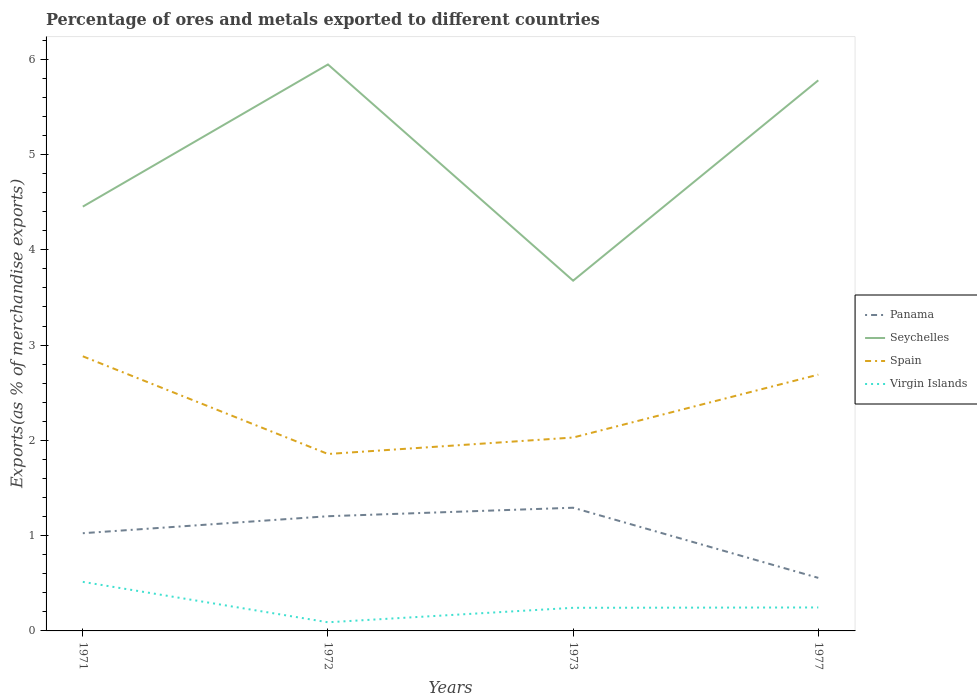How many different coloured lines are there?
Your answer should be very brief. 4. Is the number of lines equal to the number of legend labels?
Ensure brevity in your answer.  Yes. Across all years, what is the maximum percentage of exports to different countries in Panama?
Give a very brief answer. 0.56. In which year was the percentage of exports to different countries in Panama maximum?
Offer a very short reply. 1977. What is the total percentage of exports to different countries in Panama in the graph?
Offer a terse response. 0.65. What is the difference between the highest and the second highest percentage of exports to different countries in Seychelles?
Keep it short and to the point. 2.27. What is the difference between the highest and the lowest percentage of exports to different countries in Spain?
Ensure brevity in your answer.  2. Is the percentage of exports to different countries in Panama strictly greater than the percentage of exports to different countries in Spain over the years?
Provide a succinct answer. Yes. How many years are there in the graph?
Keep it short and to the point. 4. Does the graph contain grids?
Your response must be concise. No. What is the title of the graph?
Provide a succinct answer. Percentage of ores and metals exported to different countries. What is the label or title of the X-axis?
Make the answer very short. Years. What is the label or title of the Y-axis?
Your answer should be compact. Exports(as % of merchandise exports). What is the Exports(as % of merchandise exports) of Panama in 1971?
Your answer should be compact. 1.03. What is the Exports(as % of merchandise exports) in Seychelles in 1971?
Provide a short and direct response. 4.45. What is the Exports(as % of merchandise exports) of Spain in 1971?
Your answer should be very brief. 2.88. What is the Exports(as % of merchandise exports) of Virgin Islands in 1971?
Provide a succinct answer. 0.51. What is the Exports(as % of merchandise exports) in Panama in 1972?
Provide a short and direct response. 1.2. What is the Exports(as % of merchandise exports) in Seychelles in 1972?
Your answer should be very brief. 5.95. What is the Exports(as % of merchandise exports) of Spain in 1972?
Offer a very short reply. 1.86. What is the Exports(as % of merchandise exports) of Virgin Islands in 1972?
Ensure brevity in your answer.  0.09. What is the Exports(as % of merchandise exports) of Panama in 1973?
Your answer should be very brief. 1.29. What is the Exports(as % of merchandise exports) in Seychelles in 1973?
Keep it short and to the point. 3.68. What is the Exports(as % of merchandise exports) of Spain in 1973?
Offer a very short reply. 2.03. What is the Exports(as % of merchandise exports) in Virgin Islands in 1973?
Keep it short and to the point. 0.24. What is the Exports(as % of merchandise exports) of Panama in 1977?
Your response must be concise. 0.56. What is the Exports(as % of merchandise exports) of Seychelles in 1977?
Your answer should be compact. 5.78. What is the Exports(as % of merchandise exports) in Spain in 1977?
Your response must be concise. 2.69. What is the Exports(as % of merchandise exports) in Virgin Islands in 1977?
Offer a terse response. 0.25. Across all years, what is the maximum Exports(as % of merchandise exports) of Panama?
Offer a terse response. 1.29. Across all years, what is the maximum Exports(as % of merchandise exports) in Seychelles?
Make the answer very short. 5.95. Across all years, what is the maximum Exports(as % of merchandise exports) of Spain?
Give a very brief answer. 2.88. Across all years, what is the maximum Exports(as % of merchandise exports) in Virgin Islands?
Your answer should be very brief. 0.51. Across all years, what is the minimum Exports(as % of merchandise exports) in Panama?
Offer a very short reply. 0.56. Across all years, what is the minimum Exports(as % of merchandise exports) of Seychelles?
Your response must be concise. 3.68. Across all years, what is the minimum Exports(as % of merchandise exports) in Spain?
Make the answer very short. 1.86. Across all years, what is the minimum Exports(as % of merchandise exports) of Virgin Islands?
Your answer should be compact. 0.09. What is the total Exports(as % of merchandise exports) in Panama in the graph?
Provide a succinct answer. 4.08. What is the total Exports(as % of merchandise exports) in Seychelles in the graph?
Your response must be concise. 19.85. What is the total Exports(as % of merchandise exports) in Spain in the graph?
Give a very brief answer. 9.46. What is the total Exports(as % of merchandise exports) in Virgin Islands in the graph?
Offer a very short reply. 1.09. What is the difference between the Exports(as % of merchandise exports) in Panama in 1971 and that in 1972?
Your answer should be compact. -0.18. What is the difference between the Exports(as % of merchandise exports) of Seychelles in 1971 and that in 1972?
Keep it short and to the point. -1.49. What is the difference between the Exports(as % of merchandise exports) of Spain in 1971 and that in 1972?
Give a very brief answer. 1.03. What is the difference between the Exports(as % of merchandise exports) of Virgin Islands in 1971 and that in 1972?
Make the answer very short. 0.42. What is the difference between the Exports(as % of merchandise exports) in Panama in 1971 and that in 1973?
Offer a terse response. -0.27. What is the difference between the Exports(as % of merchandise exports) in Seychelles in 1971 and that in 1973?
Your answer should be compact. 0.78. What is the difference between the Exports(as % of merchandise exports) in Spain in 1971 and that in 1973?
Give a very brief answer. 0.85. What is the difference between the Exports(as % of merchandise exports) of Virgin Islands in 1971 and that in 1973?
Give a very brief answer. 0.27. What is the difference between the Exports(as % of merchandise exports) in Panama in 1971 and that in 1977?
Offer a very short reply. 0.47. What is the difference between the Exports(as % of merchandise exports) of Seychelles in 1971 and that in 1977?
Offer a very short reply. -1.33. What is the difference between the Exports(as % of merchandise exports) in Spain in 1971 and that in 1977?
Provide a short and direct response. 0.19. What is the difference between the Exports(as % of merchandise exports) of Virgin Islands in 1971 and that in 1977?
Offer a very short reply. 0.27. What is the difference between the Exports(as % of merchandise exports) of Panama in 1972 and that in 1973?
Your response must be concise. -0.09. What is the difference between the Exports(as % of merchandise exports) of Seychelles in 1972 and that in 1973?
Offer a terse response. 2.27. What is the difference between the Exports(as % of merchandise exports) in Spain in 1972 and that in 1973?
Your answer should be very brief. -0.17. What is the difference between the Exports(as % of merchandise exports) of Virgin Islands in 1972 and that in 1973?
Your answer should be compact. -0.15. What is the difference between the Exports(as % of merchandise exports) of Panama in 1972 and that in 1977?
Offer a very short reply. 0.65. What is the difference between the Exports(as % of merchandise exports) of Seychelles in 1972 and that in 1977?
Keep it short and to the point. 0.17. What is the difference between the Exports(as % of merchandise exports) of Spain in 1972 and that in 1977?
Keep it short and to the point. -0.83. What is the difference between the Exports(as % of merchandise exports) in Virgin Islands in 1972 and that in 1977?
Ensure brevity in your answer.  -0.16. What is the difference between the Exports(as % of merchandise exports) in Panama in 1973 and that in 1977?
Make the answer very short. 0.74. What is the difference between the Exports(as % of merchandise exports) of Seychelles in 1973 and that in 1977?
Keep it short and to the point. -2.1. What is the difference between the Exports(as % of merchandise exports) of Spain in 1973 and that in 1977?
Your answer should be very brief. -0.66. What is the difference between the Exports(as % of merchandise exports) in Virgin Islands in 1973 and that in 1977?
Your response must be concise. -0. What is the difference between the Exports(as % of merchandise exports) in Panama in 1971 and the Exports(as % of merchandise exports) in Seychelles in 1972?
Ensure brevity in your answer.  -4.92. What is the difference between the Exports(as % of merchandise exports) of Panama in 1971 and the Exports(as % of merchandise exports) of Spain in 1972?
Give a very brief answer. -0.83. What is the difference between the Exports(as % of merchandise exports) in Panama in 1971 and the Exports(as % of merchandise exports) in Virgin Islands in 1972?
Ensure brevity in your answer.  0.93. What is the difference between the Exports(as % of merchandise exports) of Seychelles in 1971 and the Exports(as % of merchandise exports) of Spain in 1972?
Give a very brief answer. 2.6. What is the difference between the Exports(as % of merchandise exports) of Seychelles in 1971 and the Exports(as % of merchandise exports) of Virgin Islands in 1972?
Make the answer very short. 4.36. What is the difference between the Exports(as % of merchandise exports) of Spain in 1971 and the Exports(as % of merchandise exports) of Virgin Islands in 1972?
Offer a terse response. 2.79. What is the difference between the Exports(as % of merchandise exports) of Panama in 1971 and the Exports(as % of merchandise exports) of Seychelles in 1973?
Keep it short and to the point. -2.65. What is the difference between the Exports(as % of merchandise exports) in Panama in 1971 and the Exports(as % of merchandise exports) in Spain in 1973?
Your response must be concise. -1. What is the difference between the Exports(as % of merchandise exports) in Panama in 1971 and the Exports(as % of merchandise exports) in Virgin Islands in 1973?
Your response must be concise. 0.78. What is the difference between the Exports(as % of merchandise exports) of Seychelles in 1971 and the Exports(as % of merchandise exports) of Spain in 1973?
Offer a very short reply. 2.42. What is the difference between the Exports(as % of merchandise exports) of Seychelles in 1971 and the Exports(as % of merchandise exports) of Virgin Islands in 1973?
Offer a terse response. 4.21. What is the difference between the Exports(as % of merchandise exports) in Spain in 1971 and the Exports(as % of merchandise exports) in Virgin Islands in 1973?
Your answer should be very brief. 2.64. What is the difference between the Exports(as % of merchandise exports) in Panama in 1971 and the Exports(as % of merchandise exports) in Seychelles in 1977?
Provide a succinct answer. -4.75. What is the difference between the Exports(as % of merchandise exports) of Panama in 1971 and the Exports(as % of merchandise exports) of Spain in 1977?
Provide a short and direct response. -1.66. What is the difference between the Exports(as % of merchandise exports) in Panama in 1971 and the Exports(as % of merchandise exports) in Virgin Islands in 1977?
Provide a succinct answer. 0.78. What is the difference between the Exports(as % of merchandise exports) of Seychelles in 1971 and the Exports(as % of merchandise exports) of Spain in 1977?
Provide a short and direct response. 1.76. What is the difference between the Exports(as % of merchandise exports) of Seychelles in 1971 and the Exports(as % of merchandise exports) of Virgin Islands in 1977?
Give a very brief answer. 4.21. What is the difference between the Exports(as % of merchandise exports) of Spain in 1971 and the Exports(as % of merchandise exports) of Virgin Islands in 1977?
Your answer should be very brief. 2.64. What is the difference between the Exports(as % of merchandise exports) of Panama in 1972 and the Exports(as % of merchandise exports) of Seychelles in 1973?
Your answer should be very brief. -2.47. What is the difference between the Exports(as % of merchandise exports) in Panama in 1972 and the Exports(as % of merchandise exports) in Spain in 1973?
Your answer should be compact. -0.83. What is the difference between the Exports(as % of merchandise exports) of Panama in 1972 and the Exports(as % of merchandise exports) of Virgin Islands in 1973?
Offer a terse response. 0.96. What is the difference between the Exports(as % of merchandise exports) of Seychelles in 1972 and the Exports(as % of merchandise exports) of Spain in 1973?
Offer a terse response. 3.92. What is the difference between the Exports(as % of merchandise exports) of Seychelles in 1972 and the Exports(as % of merchandise exports) of Virgin Islands in 1973?
Your answer should be very brief. 5.7. What is the difference between the Exports(as % of merchandise exports) in Spain in 1972 and the Exports(as % of merchandise exports) in Virgin Islands in 1973?
Offer a very short reply. 1.61. What is the difference between the Exports(as % of merchandise exports) of Panama in 1972 and the Exports(as % of merchandise exports) of Seychelles in 1977?
Offer a very short reply. -4.58. What is the difference between the Exports(as % of merchandise exports) in Panama in 1972 and the Exports(as % of merchandise exports) in Spain in 1977?
Make the answer very short. -1.49. What is the difference between the Exports(as % of merchandise exports) of Panama in 1972 and the Exports(as % of merchandise exports) of Virgin Islands in 1977?
Give a very brief answer. 0.96. What is the difference between the Exports(as % of merchandise exports) in Seychelles in 1972 and the Exports(as % of merchandise exports) in Spain in 1977?
Provide a succinct answer. 3.26. What is the difference between the Exports(as % of merchandise exports) in Seychelles in 1972 and the Exports(as % of merchandise exports) in Virgin Islands in 1977?
Give a very brief answer. 5.7. What is the difference between the Exports(as % of merchandise exports) of Spain in 1972 and the Exports(as % of merchandise exports) of Virgin Islands in 1977?
Make the answer very short. 1.61. What is the difference between the Exports(as % of merchandise exports) of Panama in 1973 and the Exports(as % of merchandise exports) of Seychelles in 1977?
Your response must be concise. -4.49. What is the difference between the Exports(as % of merchandise exports) in Panama in 1973 and the Exports(as % of merchandise exports) in Spain in 1977?
Offer a very short reply. -1.4. What is the difference between the Exports(as % of merchandise exports) of Panama in 1973 and the Exports(as % of merchandise exports) of Virgin Islands in 1977?
Offer a terse response. 1.05. What is the difference between the Exports(as % of merchandise exports) in Seychelles in 1973 and the Exports(as % of merchandise exports) in Spain in 1977?
Provide a succinct answer. 0.99. What is the difference between the Exports(as % of merchandise exports) of Seychelles in 1973 and the Exports(as % of merchandise exports) of Virgin Islands in 1977?
Offer a terse response. 3.43. What is the difference between the Exports(as % of merchandise exports) in Spain in 1973 and the Exports(as % of merchandise exports) in Virgin Islands in 1977?
Your answer should be very brief. 1.78. What is the average Exports(as % of merchandise exports) of Panama per year?
Keep it short and to the point. 1.02. What is the average Exports(as % of merchandise exports) in Seychelles per year?
Offer a very short reply. 4.96. What is the average Exports(as % of merchandise exports) of Spain per year?
Offer a terse response. 2.36. What is the average Exports(as % of merchandise exports) of Virgin Islands per year?
Ensure brevity in your answer.  0.27. In the year 1971, what is the difference between the Exports(as % of merchandise exports) of Panama and Exports(as % of merchandise exports) of Seychelles?
Ensure brevity in your answer.  -3.43. In the year 1971, what is the difference between the Exports(as % of merchandise exports) in Panama and Exports(as % of merchandise exports) in Spain?
Provide a succinct answer. -1.86. In the year 1971, what is the difference between the Exports(as % of merchandise exports) of Panama and Exports(as % of merchandise exports) of Virgin Islands?
Your answer should be very brief. 0.51. In the year 1971, what is the difference between the Exports(as % of merchandise exports) of Seychelles and Exports(as % of merchandise exports) of Spain?
Your response must be concise. 1.57. In the year 1971, what is the difference between the Exports(as % of merchandise exports) of Seychelles and Exports(as % of merchandise exports) of Virgin Islands?
Your answer should be very brief. 3.94. In the year 1971, what is the difference between the Exports(as % of merchandise exports) in Spain and Exports(as % of merchandise exports) in Virgin Islands?
Your response must be concise. 2.37. In the year 1972, what is the difference between the Exports(as % of merchandise exports) of Panama and Exports(as % of merchandise exports) of Seychelles?
Give a very brief answer. -4.74. In the year 1972, what is the difference between the Exports(as % of merchandise exports) of Panama and Exports(as % of merchandise exports) of Spain?
Ensure brevity in your answer.  -0.65. In the year 1972, what is the difference between the Exports(as % of merchandise exports) in Panama and Exports(as % of merchandise exports) in Virgin Islands?
Your answer should be compact. 1.11. In the year 1972, what is the difference between the Exports(as % of merchandise exports) in Seychelles and Exports(as % of merchandise exports) in Spain?
Ensure brevity in your answer.  4.09. In the year 1972, what is the difference between the Exports(as % of merchandise exports) of Seychelles and Exports(as % of merchandise exports) of Virgin Islands?
Give a very brief answer. 5.85. In the year 1972, what is the difference between the Exports(as % of merchandise exports) in Spain and Exports(as % of merchandise exports) in Virgin Islands?
Keep it short and to the point. 1.77. In the year 1973, what is the difference between the Exports(as % of merchandise exports) of Panama and Exports(as % of merchandise exports) of Seychelles?
Offer a terse response. -2.38. In the year 1973, what is the difference between the Exports(as % of merchandise exports) in Panama and Exports(as % of merchandise exports) in Spain?
Your answer should be very brief. -0.74. In the year 1973, what is the difference between the Exports(as % of merchandise exports) in Panama and Exports(as % of merchandise exports) in Virgin Islands?
Your answer should be very brief. 1.05. In the year 1973, what is the difference between the Exports(as % of merchandise exports) in Seychelles and Exports(as % of merchandise exports) in Spain?
Give a very brief answer. 1.65. In the year 1973, what is the difference between the Exports(as % of merchandise exports) of Seychelles and Exports(as % of merchandise exports) of Virgin Islands?
Keep it short and to the point. 3.43. In the year 1973, what is the difference between the Exports(as % of merchandise exports) in Spain and Exports(as % of merchandise exports) in Virgin Islands?
Your response must be concise. 1.79. In the year 1977, what is the difference between the Exports(as % of merchandise exports) of Panama and Exports(as % of merchandise exports) of Seychelles?
Keep it short and to the point. -5.22. In the year 1977, what is the difference between the Exports(as % of merchandise exports) of Panama and Exports(as % of merchandise exports) of Spain?
Keep it short and to the point. -2.13. In the year 1977, what is the difference between the Exports(as % of merchandise exports) in Panama and Exports(as % of merchandise exports) in Virgin Islands?
Make the answer very short. 0.31. In the year 1977, what is the difference between the Exports(as % of merchandise exports) of Seychelles and Exports(as % of merchandise exports) of Spain?
Offer a very short reply. 3.09. In the year 1977, what is the difference between the Exports(as % of merchandise exports) of Seychelles and Exports(as % of merchandise exports) of Virgin Islands?
Ensure brevity in your answer.  5.53. In the year 1977, what is the difference between the Exports(as % of merchandise exports) of Spain and Exports(as % of merchandise exports) of Virgin Islands?
Your answer should be very brief. 2.44. What is the ratio of the Exports(as % of merchandise exports) in Panama in 1971 to that in 1972?
Your answer should be compact. 0.85. What is the ratio of the Exports(as % of merchandise exports) in Seychelles in 1971 to that in 1972?
Offer a terse response. 0.75. What is the ratio of the Exports(as % of merchandise exports) in Spain in 1971 to that in 1972?
Make the answer very short. 1.55. What is the ratio of the Exports(as % of merchandise exports) of Virgin Islands in 1971 to that in 1972?
Keep it short and to the point. 5.67. What is the ratio of the Exports(as % of merchandise exports) of Panama in 1971 to that in 1973?
Provide a short and direct response. 0.79. What is the ratio of the Exports(as % of merchandise exports) in Seychelles in 1971 to that in 1973?
Your answer should be very brief. 1.21. What is the ratio of the Exports(as % of merchandise exports) of Spain in 1971 to that in 1973?
Make the answer very short. 1.42. What is the ratio of the Exports(as % of merchandise exports) in Virgin Islands in 1971 to that in 1973?
Keep it short and to the point. 2.12. What is the ratio of the Exports(as % of merchandise exports) of Panama in 1971 to that in 1977?
Provide a succinct answer. 1.84. What is the ratio of the Exports(as % of merchandise exports) of Seychelles in 1971 to that in 1977?
Your answer should be compact. 0.77. What is the ratio of the Exports(as % of merchandise exports) of Spain in 1971 to that in 1977?
Make the answer very short. 1.07. What is the ratio of the Exports(as % of merchandise exports) in Virgin Islands in 1971 to that in 1977?
Keep it short and to the point. 2.09. What is the ratio of the Exports(as % of merchandise exports) in Panama in 1972 to that in 1973?
Offer a terse response. 0.93. What is the ratio of the Exports(as % of merchandise exports) in Seychelles in 1972 to that in 1973?
Ensure brevity in your answer.  1.62. What is the ratio of the Exports(as % of merchandise exports) of Spain in 1972 to that in 1973?
Make the answer very short. 0.91. What is the ratio of the Exports(as % of merchandise exports) in Virgin Islands in 1972 to that in 1973?
Make the answer very short. 0.37. What is the ratio of the Exports(as % of merchandise exports) of Panama in 1972 to that in 1977?
Give a very brief answer. 2.16. What is the ratio of the Exports(as % of merchandise exports) in Seychelles in 1972 to that in 1977?
Offer a very short reply. 1.03. What is the ratio of the Exports(as % of merchandise exports) of Spain in 1972 to that in 1977?
Ensure brevity in your answer.  0.69. What is the ratio of the Exports(as % of merchandise exports) in Virgin Islands in 1972 to that in 1977?
Ensure brevity in your answer.  0.37. What is the ratio of the Exports(as % of merchandise exports) in Panama in 1973 to that in 1977?
Your answer should be compact. 2.32. What is the ratio of the Exports(as % of merchandise exports) in Seychelles in 1973 to that in 1977?
Your answer should be compact. 0.64. What is the ratio of the Exports(as % of merchandise exports) of Spain in 1973 to that in 1977?
Ensure brevity in your answer.  0.75. What is the ratio of the Exports(as % of merchandise exports) in Virgin Islands in 1973 to that in 1977?
Your response must be concise. 0.99. What is the difference between the highest and the second highest Exports(as % of merchandise exports) of Panama?
Give a very brief answer. 0.09. What is the difference between the highest and the second highest Exports(as % of merchandise exports) of Seychelles?
Make the answer very short. 0.17. What is the difference between the highest and the second highest Exports(as % of merchandise exports) in Spain?
Keep it short and to the point. 0.19. What is the difference between the highest and the second highest Exports(as % of merchandise exports) of Virgin Islands?
Give a very brief answer. 0.27. What is the difference between the highest and the lowest Exports(as % of merchandise exports) in Panama?
Your answer should be very brief. 0.74. What is the difference between the highest and the lowest Exports(as % of merchandise exports) of Seychelles?
Offer a terse response. 2.27. What is the difference between the highest and the lowest Exports(as % of merchandise exports) of Spain?
Your response must be concise. 1.03. What is the difference between the highest and the lowest Exports(as % of merchandise exports) in Virgin Islands?
Ensure brevity in your answer.  0.42. 